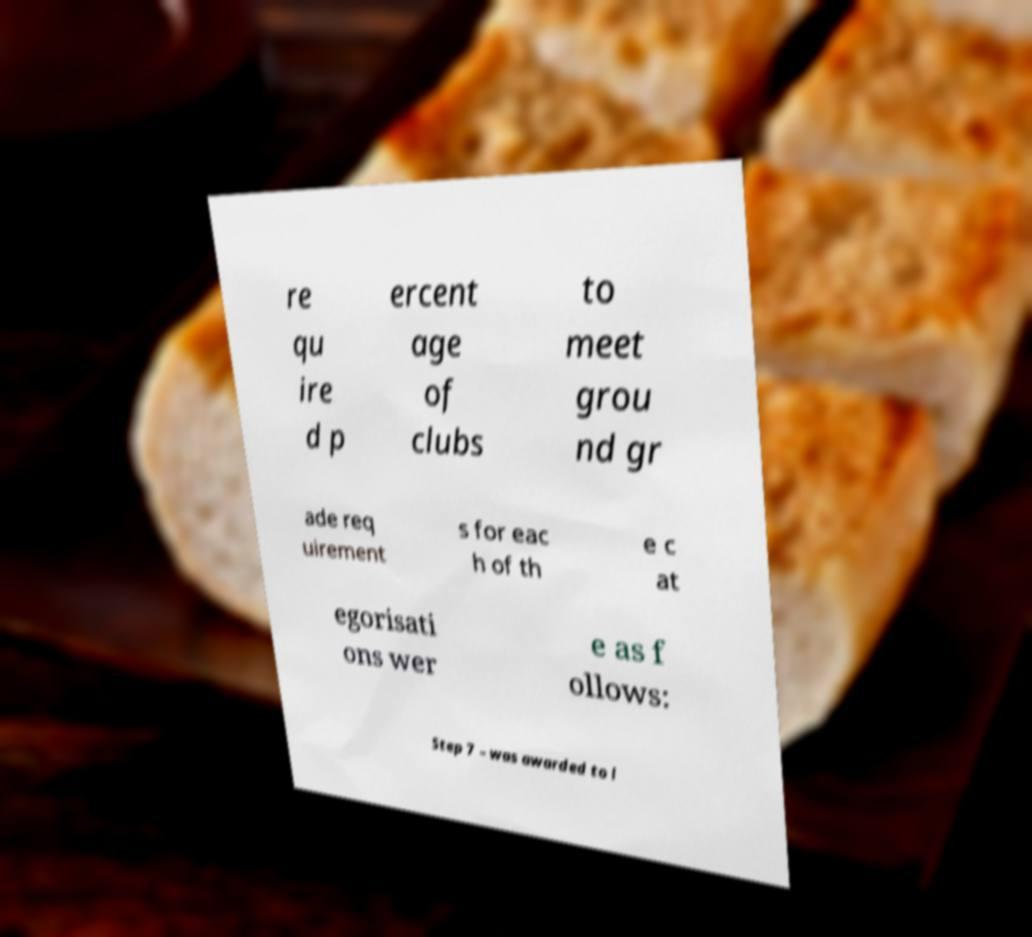Please read and relay the text visible in this image. What does it say? re qu ire d p ercent age of clubs to meet grou nd gr ade req uirement s for eac h of th e c at egorisati ons wer e as f ollows: Step 7 – was awarded to l 